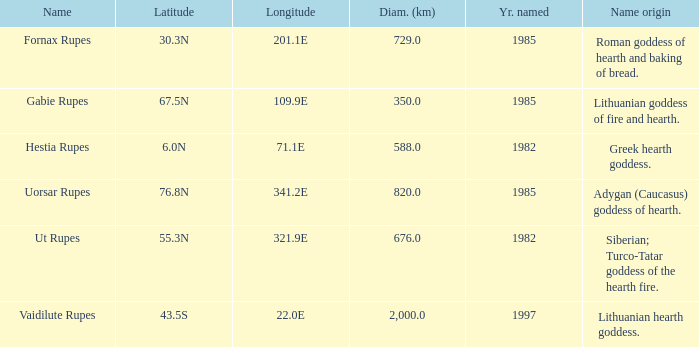At a latitude of 67.5n, what is the diameter? 350.0. 